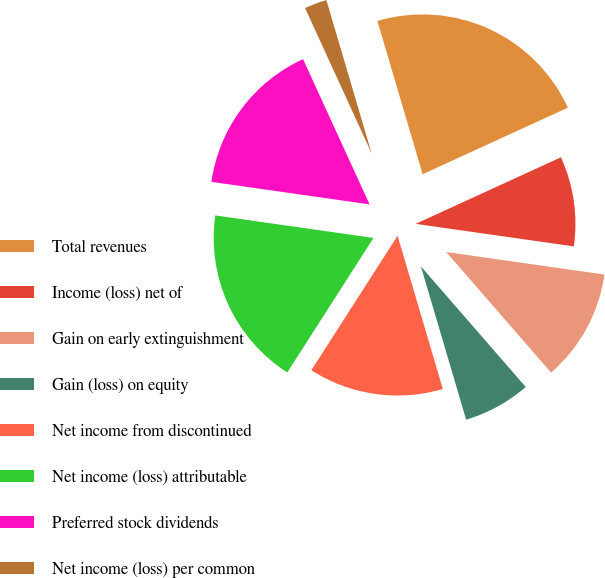Convert chart to OTSL. <chart><loc_0><loc_0><loc_500><loc_500><pie_chart><fcel>Total revenues<fcel>Income (loss) net of<fcel>Gain on early extinguishment<fcel>Gain (loss) on equity<fcel>Net income from discontinued<fcel>Net income (loss) attributable<fcel>Preferred stock dividends<fcel>Net income (loss) per common<nl><fcel>22.73%<fcel>9.09%<fcel>11.36%<fcel>6.82%<fcel>13.64%<fcel>18.18%<fcel>15.91%<fcel>2.27%<nl></chart> 